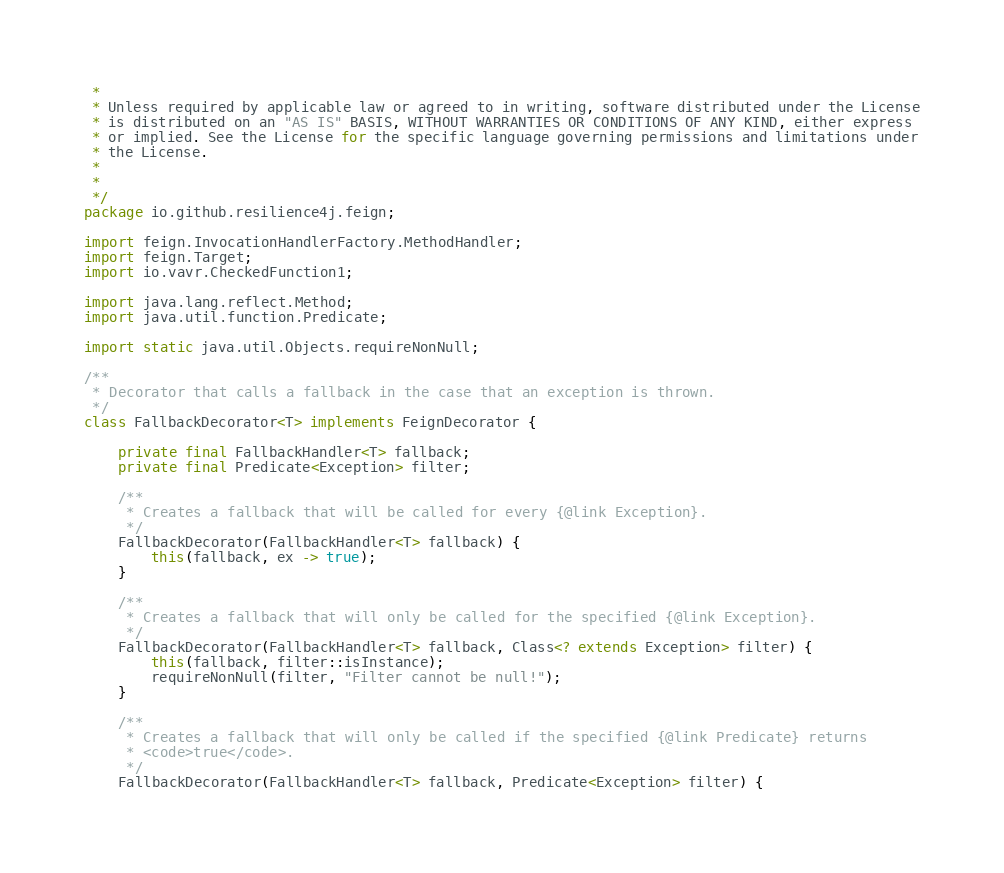<code> <loc_0><loc_0><loc_500><loc_500><_Java_> *
 * Unless required by applicable law or agreed to in writing, software distributed under the License
 * is distributed on an "AS IS" BASIS, WITHOUT WARRANTIES OR CONDITIONS OF ANY KIND, either express
 * or implied. See the License for the specific language governing permissions and limitations under
 * the License.
 *
 *
 */
package io.github.resilience4j.feign;

import feign.InvocationHandlerFactory.MethodHandler;
import feign.Target;
import io.vavr.CheckedFunction1;

import java.lang.reflect.Method;
import java.util.function.Predicate;

import static java.util.Objects.requireNonNull;

/**
 * Decorator that calls a fallback in the case that an exception is thrown.
 */
class FallbackDecorator<T> implements FeignDecorator {

    private final FallbackHandler<T> fallback;
    private final Predicate<Exception> filter;

    /**
     * Creates a fallback that will be called for every {@link Exception}.
     */
    FallbackDecorator(FallbackHandler<T> fallback) {
        this(fallback, ex -> true);
    }

    /**
     * Creates a fallback that will only be called for the specified {@link Exception}.
     */
    FallbackDecorator(FallbackHandler<T> fallback, Class<? extends Exception> filter) {
        this(fallback, filter::isInstance);
        requireNonNull(filter, "Filter cannot be null!");
    }

    /**
     * Creates a fallback that will only be called if the specified {@link Predicate} returns
     * <code>true</code>.
     */
    FallbackDecorator(FallbackHandler<T> fallback, Predicate<Exception> filter) {</code> 